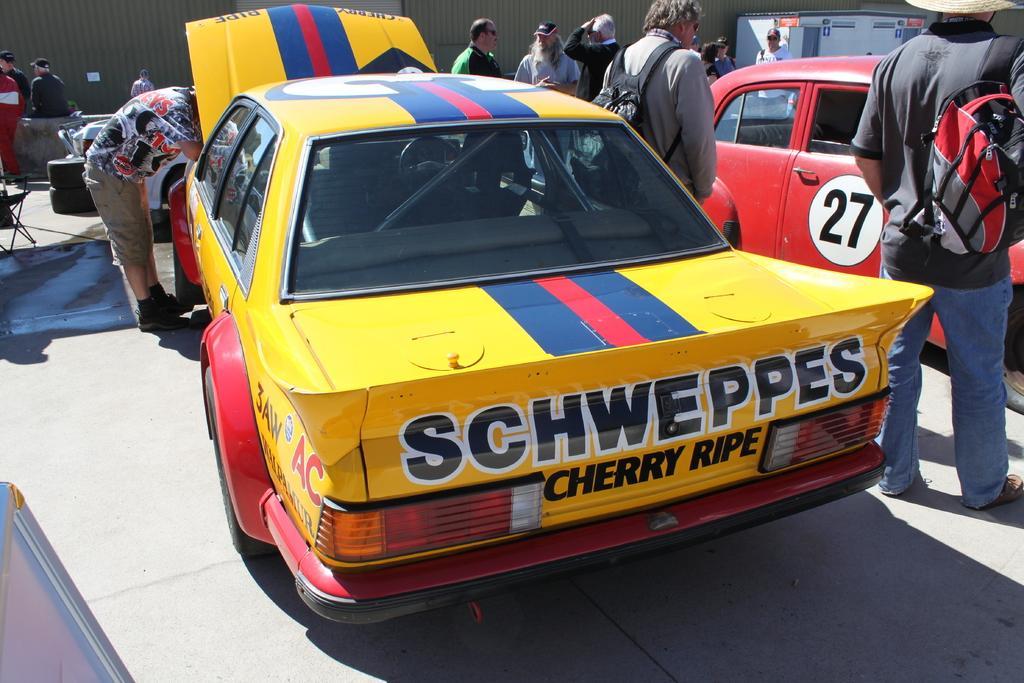Please provide a concise description of this image. In this picture, there is a car in the center which is in red and yellow in color. Beside the car, there is a man. Towards the right, there is another man wearing black t shirt, blue jeans and carrying a bag. Before him, there is another car which is in red in color. On the top, there are people. In the background there are people. 